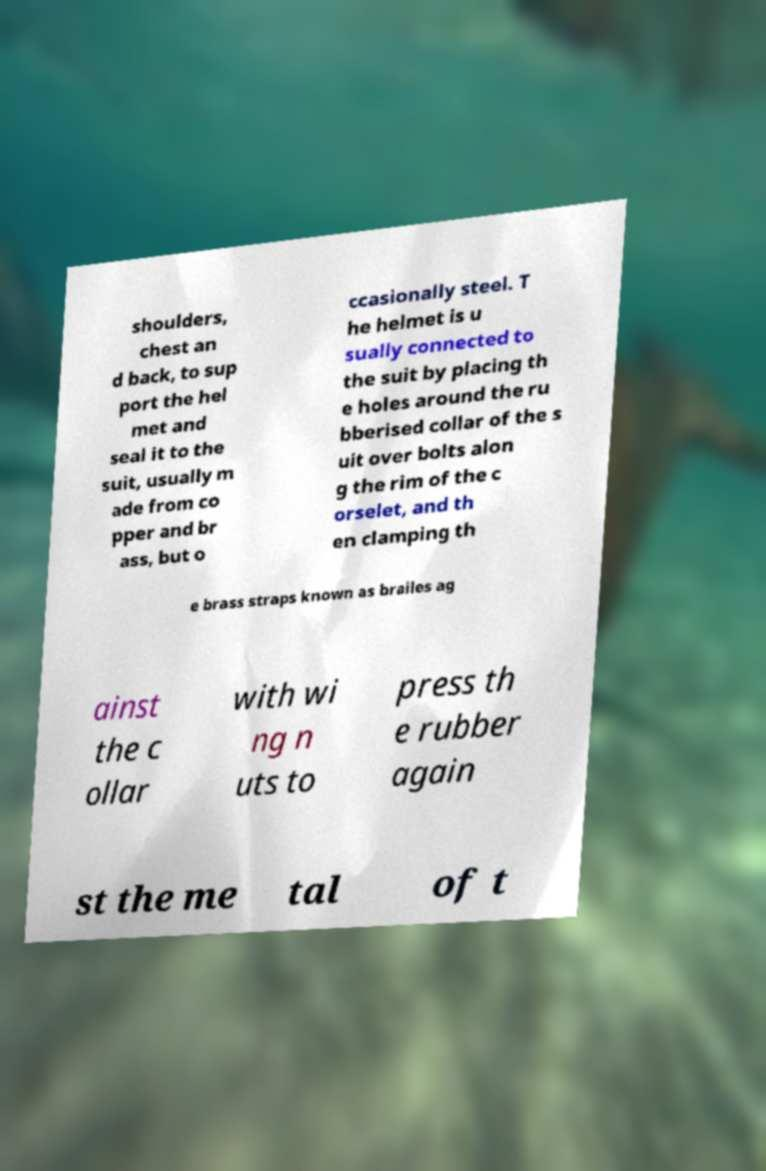What messages or text are displayed in this image? I need them in a readable, typed format. shoulders, chest an d back, to sup port the hel met and seal it to the suit, usually m ade from co pper and br ass, but o ccasionally steel. T he helmet is u sually connected to the suit by placing th e holes around the ru bberised collar of the s uit over bolts alon g the rim of the c orselet, and th en clamping th e brass straps known as brailes ag ainst the c ollar with wi ng n uts to press th e rubber again st the me tal of t 